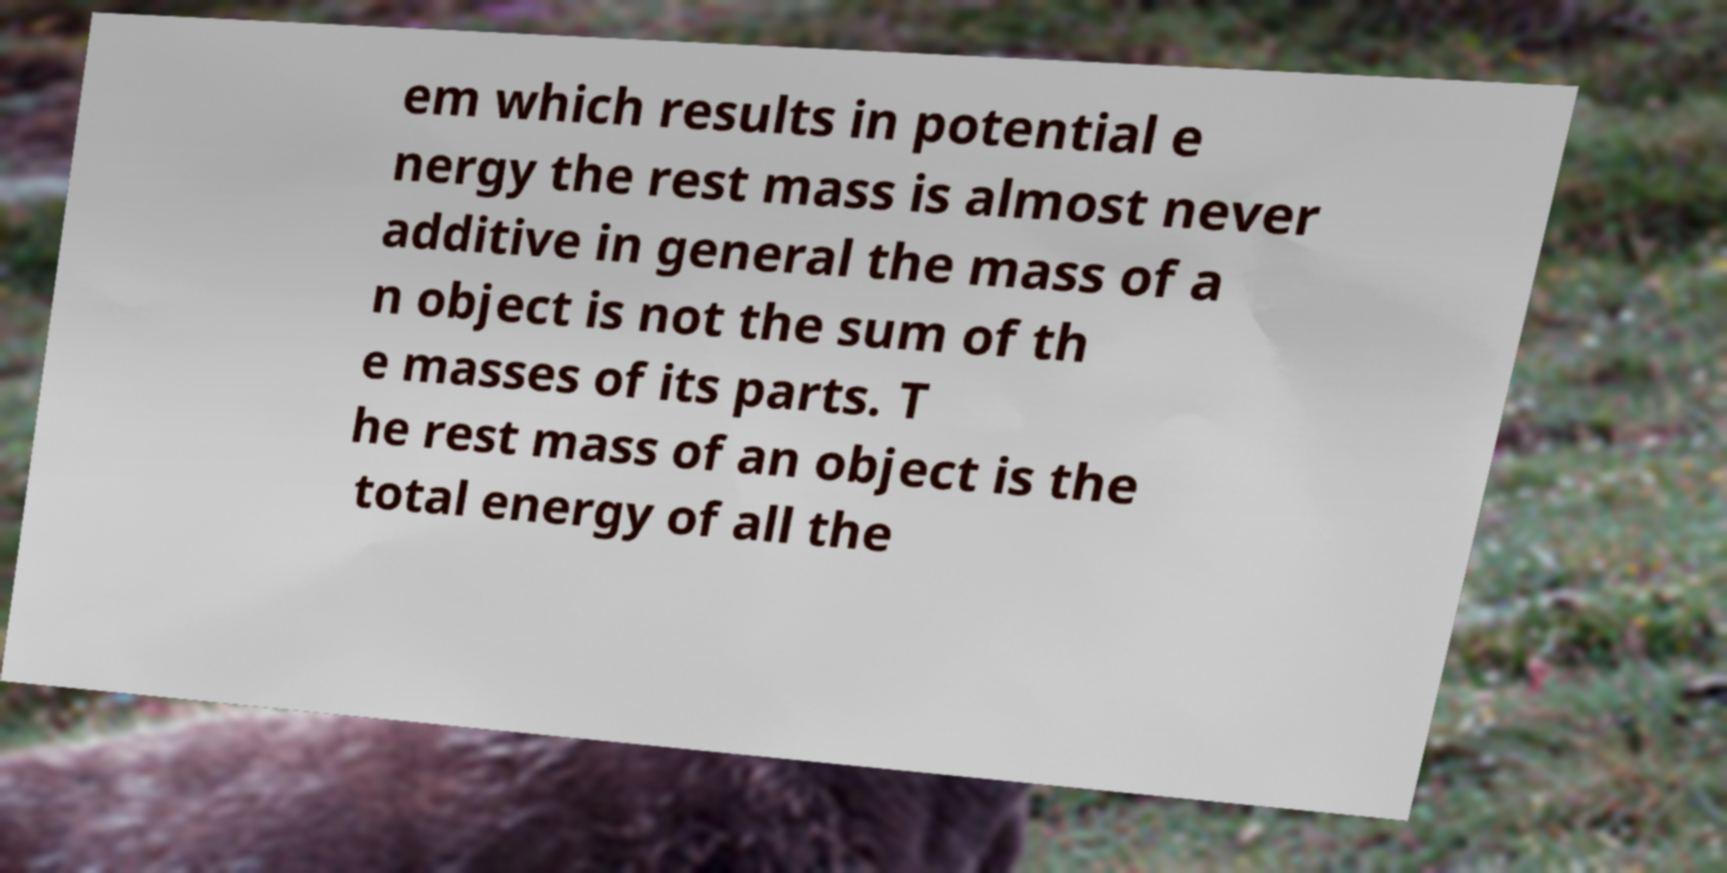I need the written content from this picture converted into text. Can you do that? em which results in potential e nergy the rest mass is almost never additive in general the mass of a n object is not the sum of th e masses of its parts. T he rest mass of an object is the total energy of all the 